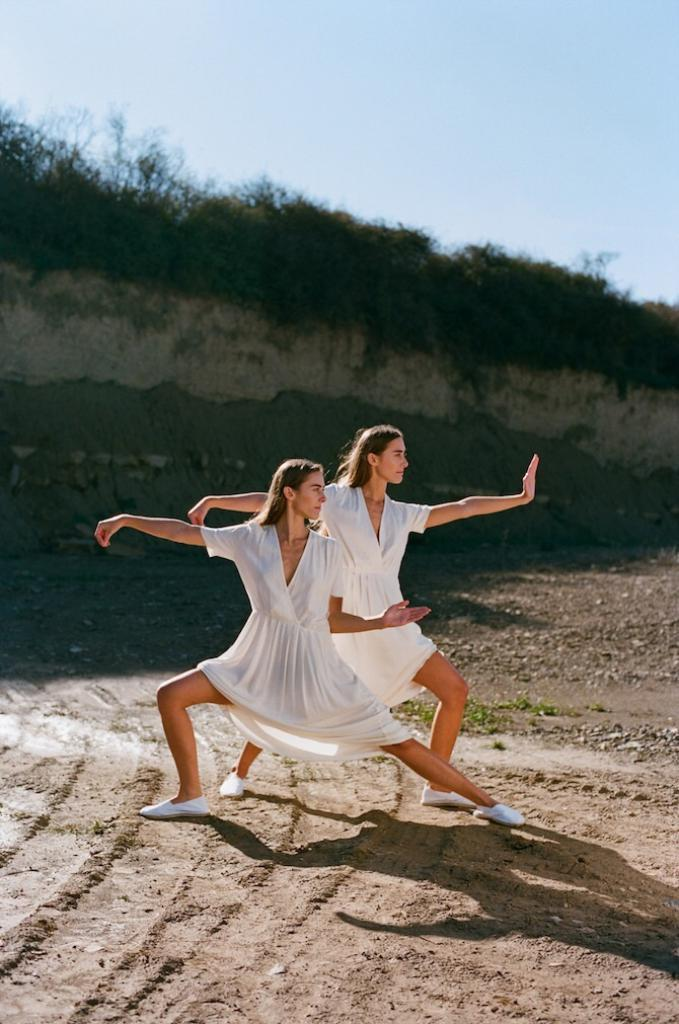How many women are in the image? There are two women in the image. What are the women wearing? The women are wearing white dresses. Where are the women standing? The women are standing on a path. What can be seen in the background of the image? Plants and the sky are visible in the background of the image. What type of agreement did the women sign in the image? There is no indication in the image that the women signed any agreement, as the focus is on their appearance and location. 